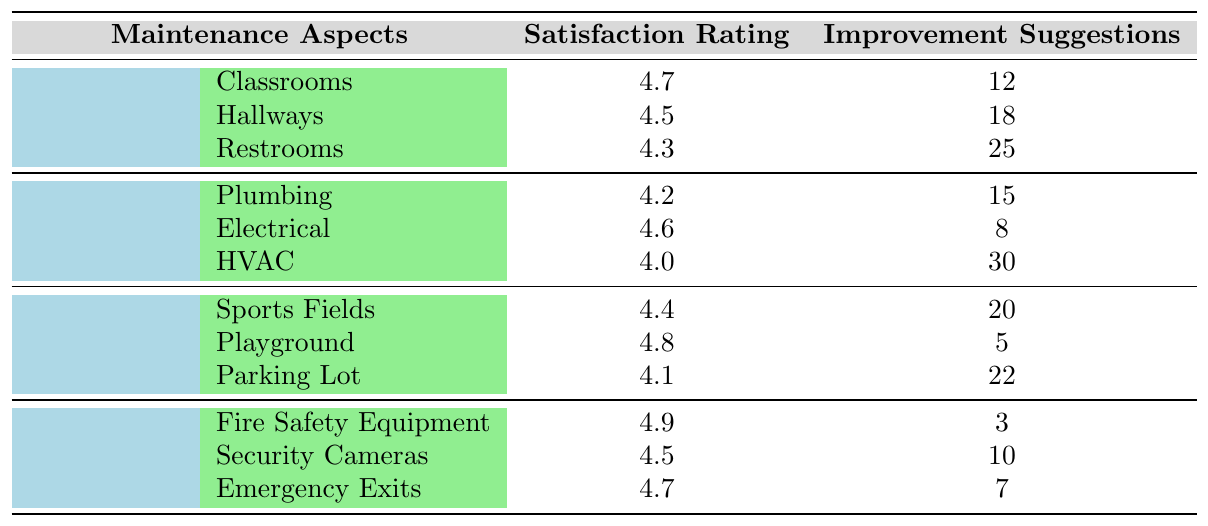What is the satisfaction rating for the restrooms? The table shows that the satisfaction rating for the restrooms under the Cleanliness category is 4.3.
Answer: 4.3 Which area has the highest satisfaction rating among all categories? The table indicates that the Fire Safety Equipment has the highest satisfaction rating of 4.9.
Answer: 4.9 How many improvement suggestions are listed for the Electrical area? The table shows that there are 8 improvement suggestions for the Electrical area under Repairs.
Answer: 8 What is the average satisfaction rating for the Grounds category? To find the average, we sum the ratings (4.4 + 4.8 + 4.1) = 13.3 and divide by 3 areas: 13.3 / 3 = 4.4333, which rounds to 4.43.
Answer: 4.43 Are there more improvement suggestions for the HVAC area than the Playground? The HVAC area has 30 improvement suggestions, while the Playground has 5, which means HVAC has more.
Answer: Yes What is the total number of improvement suggestions across all areas in the Safety category? We add the improvement suggestions for Fire Safety Equipment (3), Security Cameras (10), and Emergency Exits (7): 3 + 10 + 7 = 20.
Answer: 20 Which area has the lowest satisfaction rating, and what is that rating? The table indicates that the area with the lowest satisfaction rating is the HVAC at 4.0.
Answer: HVAC, 4.0 How does the average satisfaction rating of Cleanliness compare to that of Repairs? For Cleanliness, the average is (4.7 + 4.5 + 4.3) / 3 = 4.5; for Repairs, it is (4.2 + 4.6 + 4.0) / 3 = 4.2667. Comparing 4.5 > 4.2667, so Cleanliness is higher.
Answer: Cleanliness is higher 